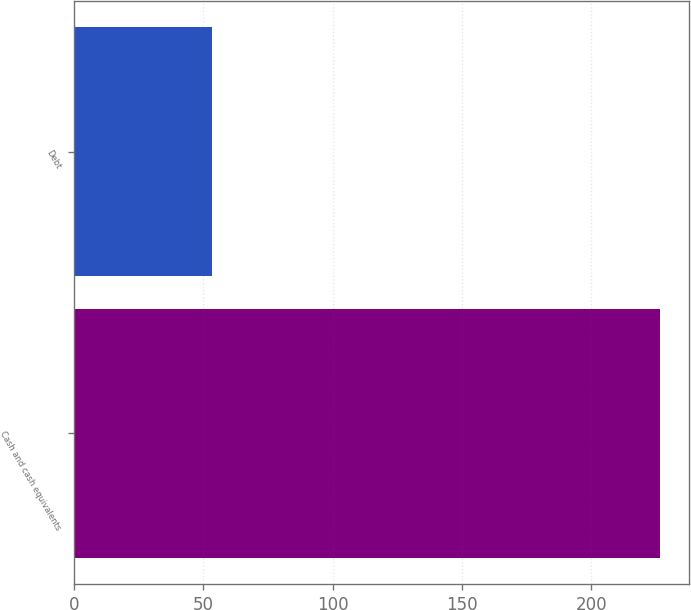Convert chart to OTSL. <chart><loc_0><loc_0><loc_500><loc_500><bar_chart><fcel>Cash and cash equivalents<fcel>Debt<nl><fcel>226.4<fcel>53.4<nl></chart> 